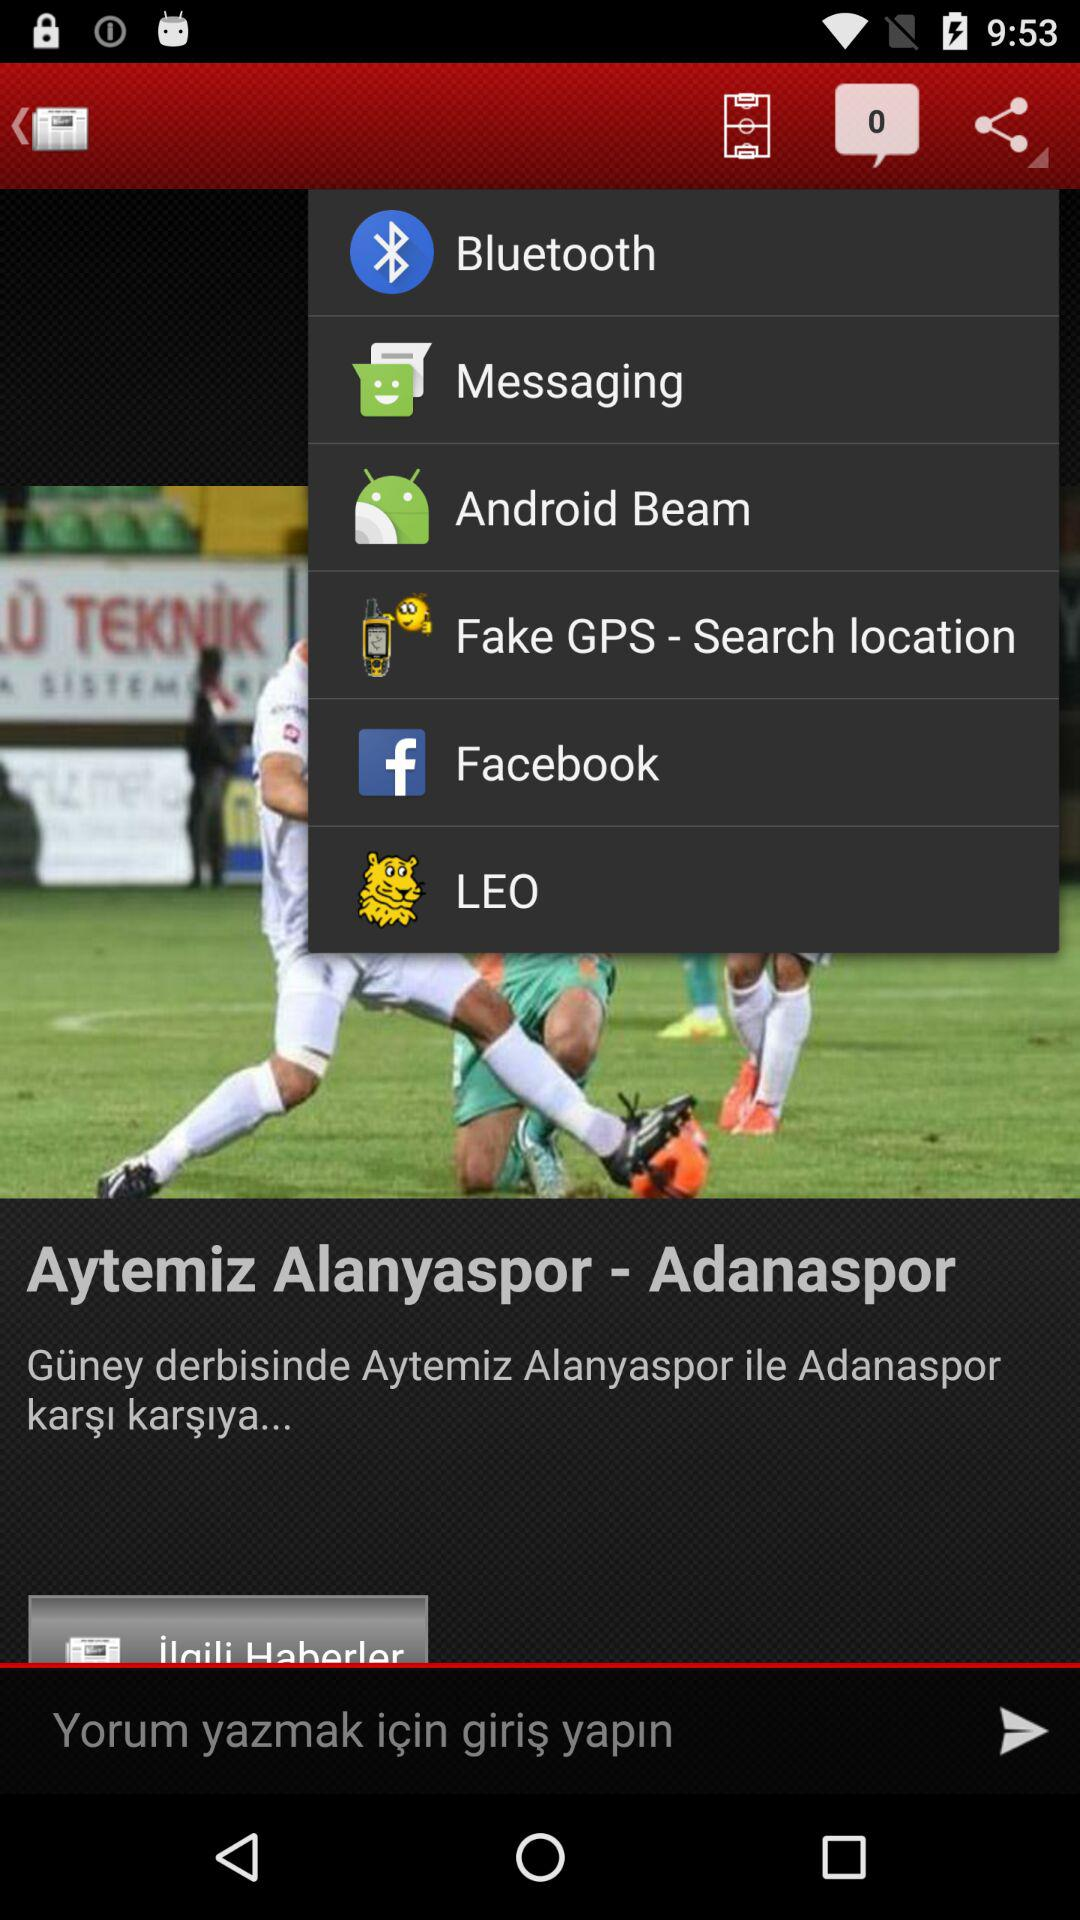How many messages are shown? The shown messages are 0. 